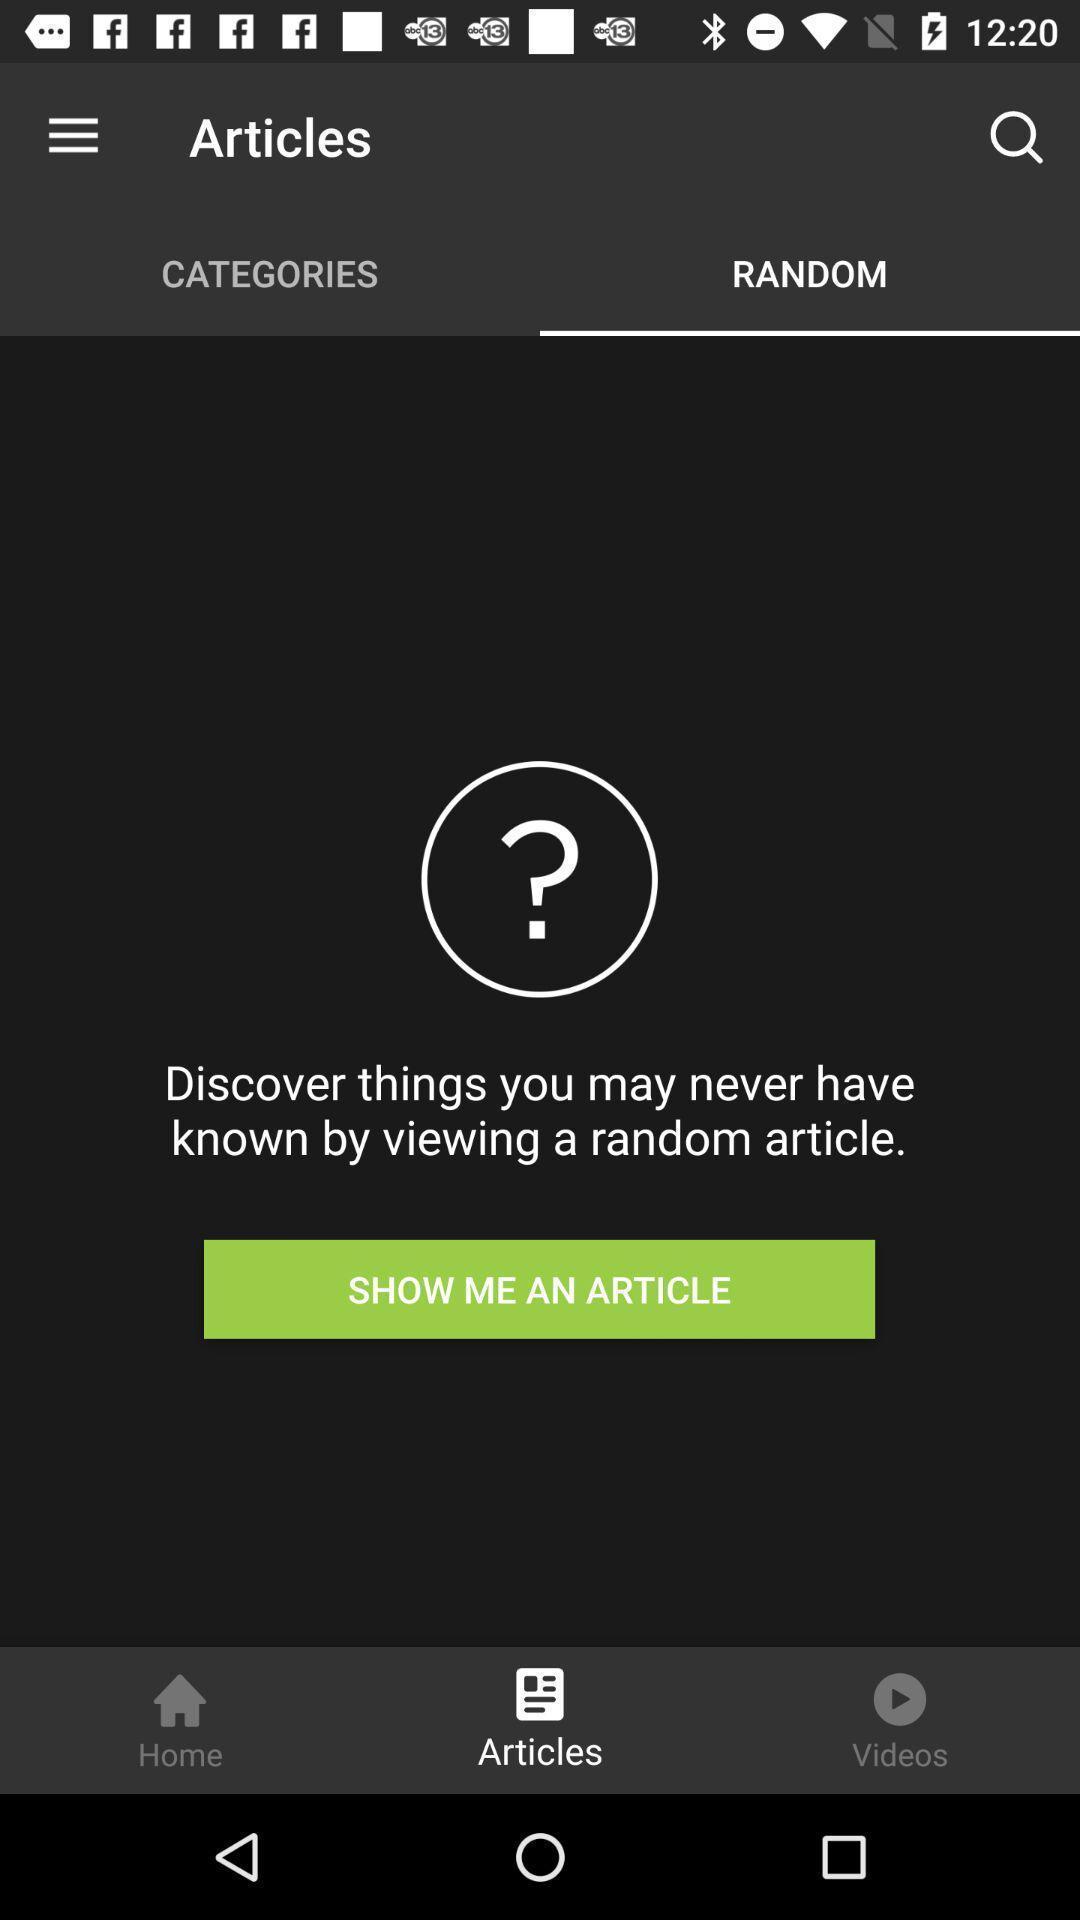Describe the content in this image. Screen displaying random articles page. 